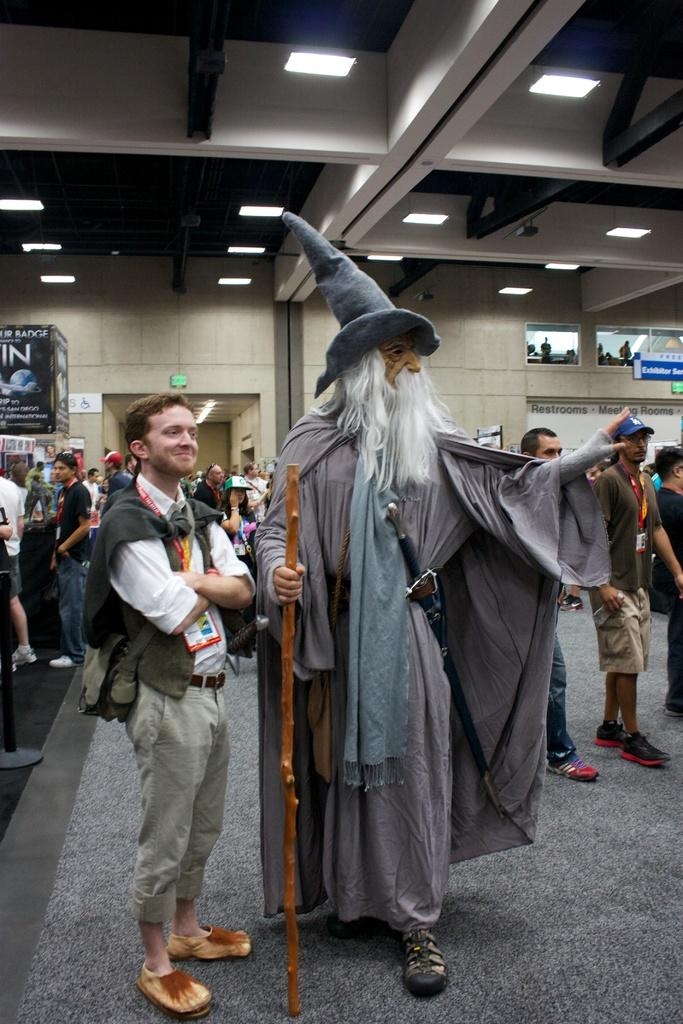How many people are in the image? There is a group of people in the image. What are the people doing in the image? The people are standing on the floor. What objects can be seen in the image? There is a pole, a stick, posters, a name board, and some other objects in the image. What can be seen in the background of the image? There is a wall, a ceiling, and lights in the background of the image. Where is the coat rack located in the image? There is no coat rack present in the image. What type of books can be seen in the library in the image? There is no library present in the image. What is the locket used for in the image? There is no locket present in the image. 